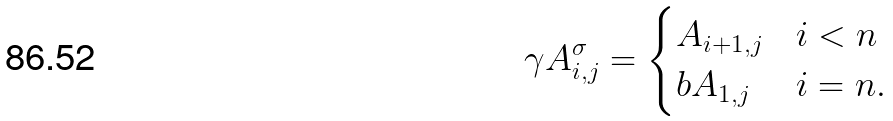<formula> <loc_0><loc_0><loc_500><loc_500>\gamma A _ { i , j } ^ { \sigma } = \begin{cases} A _ { i + 1 , j } & i < n \\ b A _ { 1 , j } & i = n . \end{cases}</formula> 